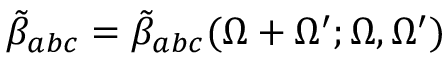<formula> <loc_0><loc_0><loc_500><loc_500>\tilde { \beta } _ { a b c } = \tilde { \beta } _ { a b c } ( \Omega + \Omega ^ { \prime } ; \Omega , \Omega ^ { \prime } )</formula> 